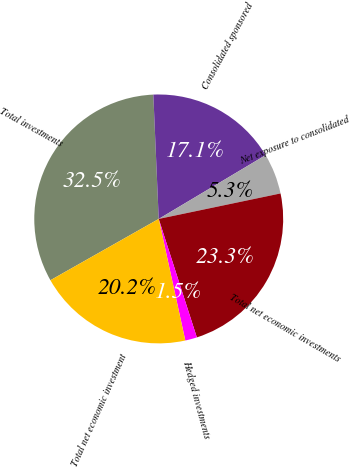Convert chart. <chart><loc_0><loc_0><loc_500><loc_500><pie_chart><fcel>Total investments<fcel>Consolidated sponsored<fcel>Net exposure to consolidated<fcel>Total net economic investments<fcel>Hedged investments<fcel>Total net economic investment<nl><fcel>32.51%<fcel>17.13%<fcel>5.28%<fcel>23.33%<fcel>1.53%<fcel>20.23%<nl></chart> 